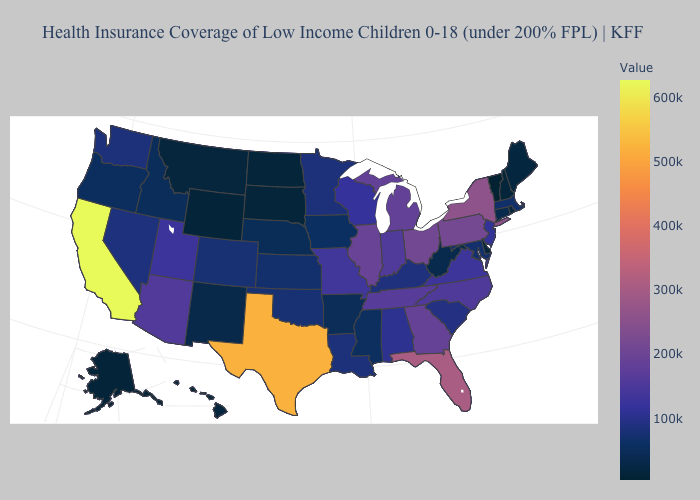Among the states that border Virginia , which have the highest value?
Keep it brief. Tennessee. 